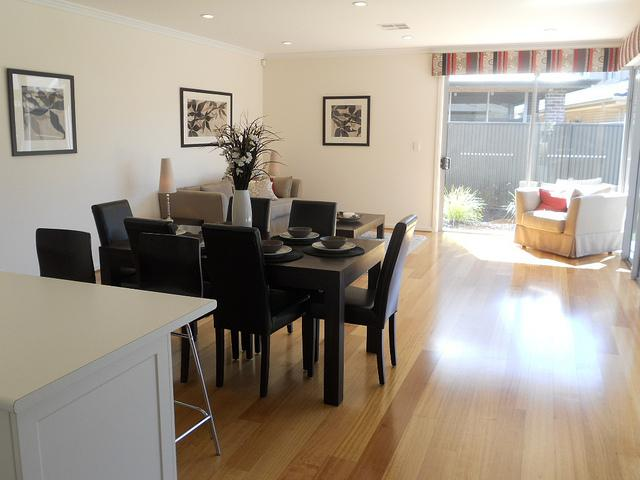What color is the seat on the couch in the corner window? Please explain your reasoning. white. The sofa is holding a red pillow. 